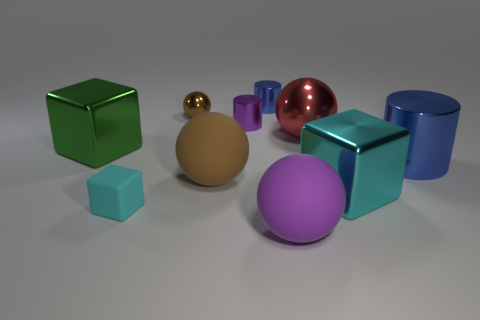Subtract all balls. How many objects are left? 6 Subtract all red metal things. Subtract all big rubber objects. How many objects are left? 7 Add 8 brown rubber things. How many brown rubber things are left? 9 Add 1 small green metallic cubes. How many small green metallic cubes exist? 1 Subtract 0 green balls. How many objects are left? 10 